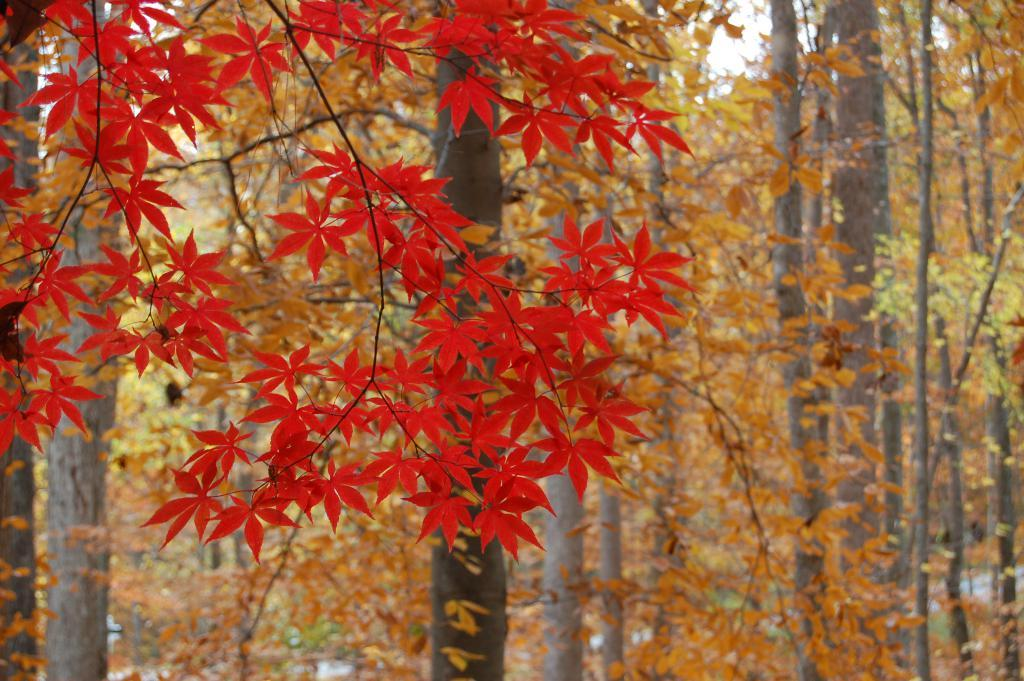What type of vegetation can be seen in the image? There are trees in the image. What part of the natural environment is visible in the image? The sky is visible in the background of the image. How many snails can be seen crawling on the trees in the image? There are no snails visible in the image; it only features trees and the sky. 